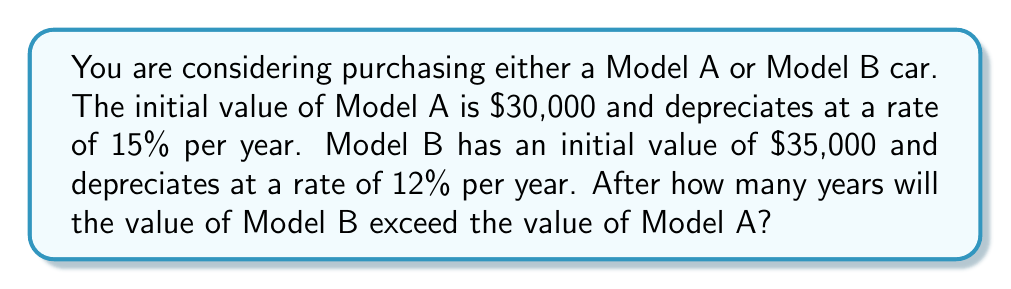Could you help me with this problem? Let's approach this step-by-step:

1) We can model the depreciation of each car using exponential decay functions:

   Model A: $A(t) = 30000 \cdot (0.85)^t$
   Model B: $B(t) = 35000 \cdot (0.88)^t$

   Where $t$ is the number of years and the base of the exponent is (1 - depreciation rate).

2) We want to find when $B(t) > A(t)$:

   $35000 \cdot (0.88)^t > 30000 \cdot (0.85)^t$

3) Divide both sides by 30000:

   $\frac{35000}{30000} \cdot (0.88)^t > (0.85)^t$

4) Simplify:

   $\frac{7}{6} \cdot (0.88)^t > (0.85)^t$

5) Take the natural log of both sides:

   $\ln(\frac{7}{6}) + t \cdot \ln(0.88) > t \cdot \ln(0.85)$

6) Subtract $t \cdot \ln(0.88)$ from both sides:

   $\ln(\frac{7}{6}) > t \cdot (\ln(0.85) - \ln(0.88))$

7) Divide both sides by $(\ln(0.85) - \ln(0.88))$:

   $t > \frac{\ln(\frac{7}{6})}{\ln(0.85) - \ln(0.88)}$

8) Calculate:

   $t > \frac{\ln(1.1667)}{-0.1744 - (-0.1278)} \approx 3.52$

9) Since we're dealing with whole years, the first year when Model B's value exceeds Model A's is year 4.
Answer: 4 years 